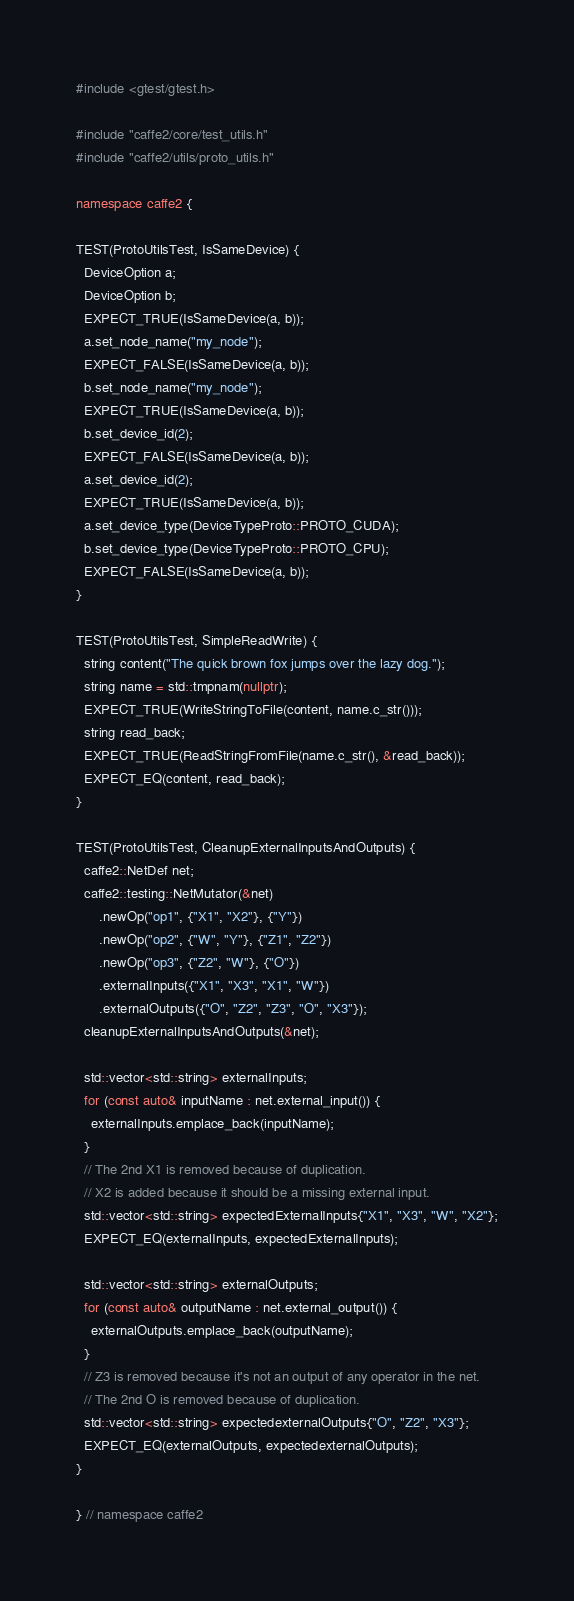<code> <loc_0><loc_0><loc_500><loc_500><_C++_>#include <gtest/gtest.h>

#include "caffe2/core/test_utils.h"
#include "caffe2/utils/proto_utils.h"

namespace caffe2 {

TEST(ProtoUtilsTest, IsSameDevice) {
  DeviceOption a;
  DeviceOption b;
  EXPECT_TRUE(IsSameDevice(a, b));
  a.set_node_name("my_node");
  EXPECT_FALSE(IsSameDevice(a, b));
  b.set_node_name("my_node");
  EXPECT_TRUE(IsSameDevice(a, b));
  b.set_device_id(2);
  EXPECT_FALSE(IsSameDevice(a, b));
  a.set_device_id(2);
  EXPECT_TRUE(IsSameDevice(a, b));
  a.set_device_type(DeviceTypeProto::PROTO_CUDA);
  b.set_device_type(DeviceTypeProto::PROTO_CPU);
  EXPECT_FALSE(IsSameDevice(a, b));
}

TEST(ProtoUtilsTest, SimpleReadWrite) {
  string content("The quick brown fox jumps over the lazy dog.");
  string name = std::tmpnam(nullptr);
  EXPECT_TRUE(WriteStringToFile(content, name.c_str()));
  string read_back;
  EXPECT_TRUE(ReadStringFromFile(name.c_str(), &read_back));
  EXPECT_EQ(content, read_back);
}

TEST(ProtoUtilsTest, CleanupExternalInputsAndOutputs) {
  caffe2::NetDef net;
  caffe2::testing::NetMutator(&net)
      .newOp("op1", {"X1", "X2"}, {"Y"})
      .newOp("op2", {"W", "Y"}, {"Z1", "Z2"})
      .newOp("op3", {"Z2", "W"}, {"O"})
      .externalInputs({"X1", "X3", "X1", "W"})
      .externalOutputs({"O", "Z2", "Z3", "O", "X3"});
  cleanupExternalInputsAndOutputs(&net);

  std::vector<std::string> externalInputs;
  for (const auto& inputName : net.external_input()) {
    externalInputs.emplace_back(inputName);
  }
  // The 2nd X1 is removed because of duplication.
  // X2 is added because it should be a missing external input.
  std::vector<std::string> expectedExternalInputs{"X1", "X3", "W", "X2"};
  EXPECT_EQ(externalInputs, expectedExternalInputs);

  std::vector<std::string> externalOutputs;
  for (const auto& outputName : net.external_output()) {
    externalOutputs.emplace_back(outputName);
  }
  // Z3 is removed because it's not an output of any operator in the net.
  // The 2nd O is removed because of duplication.
  std::vector<std::string> expectedexternalOutputs{"O", "Z2", "X3"};
  EXPECT_EQ(externalOutputs, expectedexternalOutputs);
}

} // namespace caffe2
</code> 